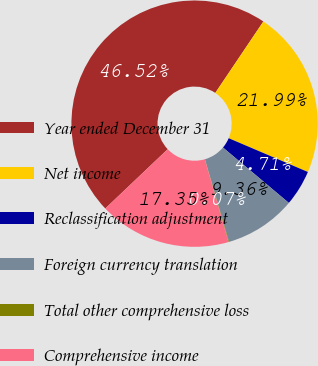<chart> <loc_0><loc_0><loc_500><loc_500><pie_chart><fcel>Year ended December 31<fcel>Net income<fcel>Reclassification adjustment<fcel>Foreign currency translation<fcel>Total other comprehensive loss<fcel>Comprehensive income<nl><fcel>46.52%<fcel>21.99%<fcel>4.71%<fcel>9.36%<fcel>0.07%<fcel>17.35%<nl></chart> 